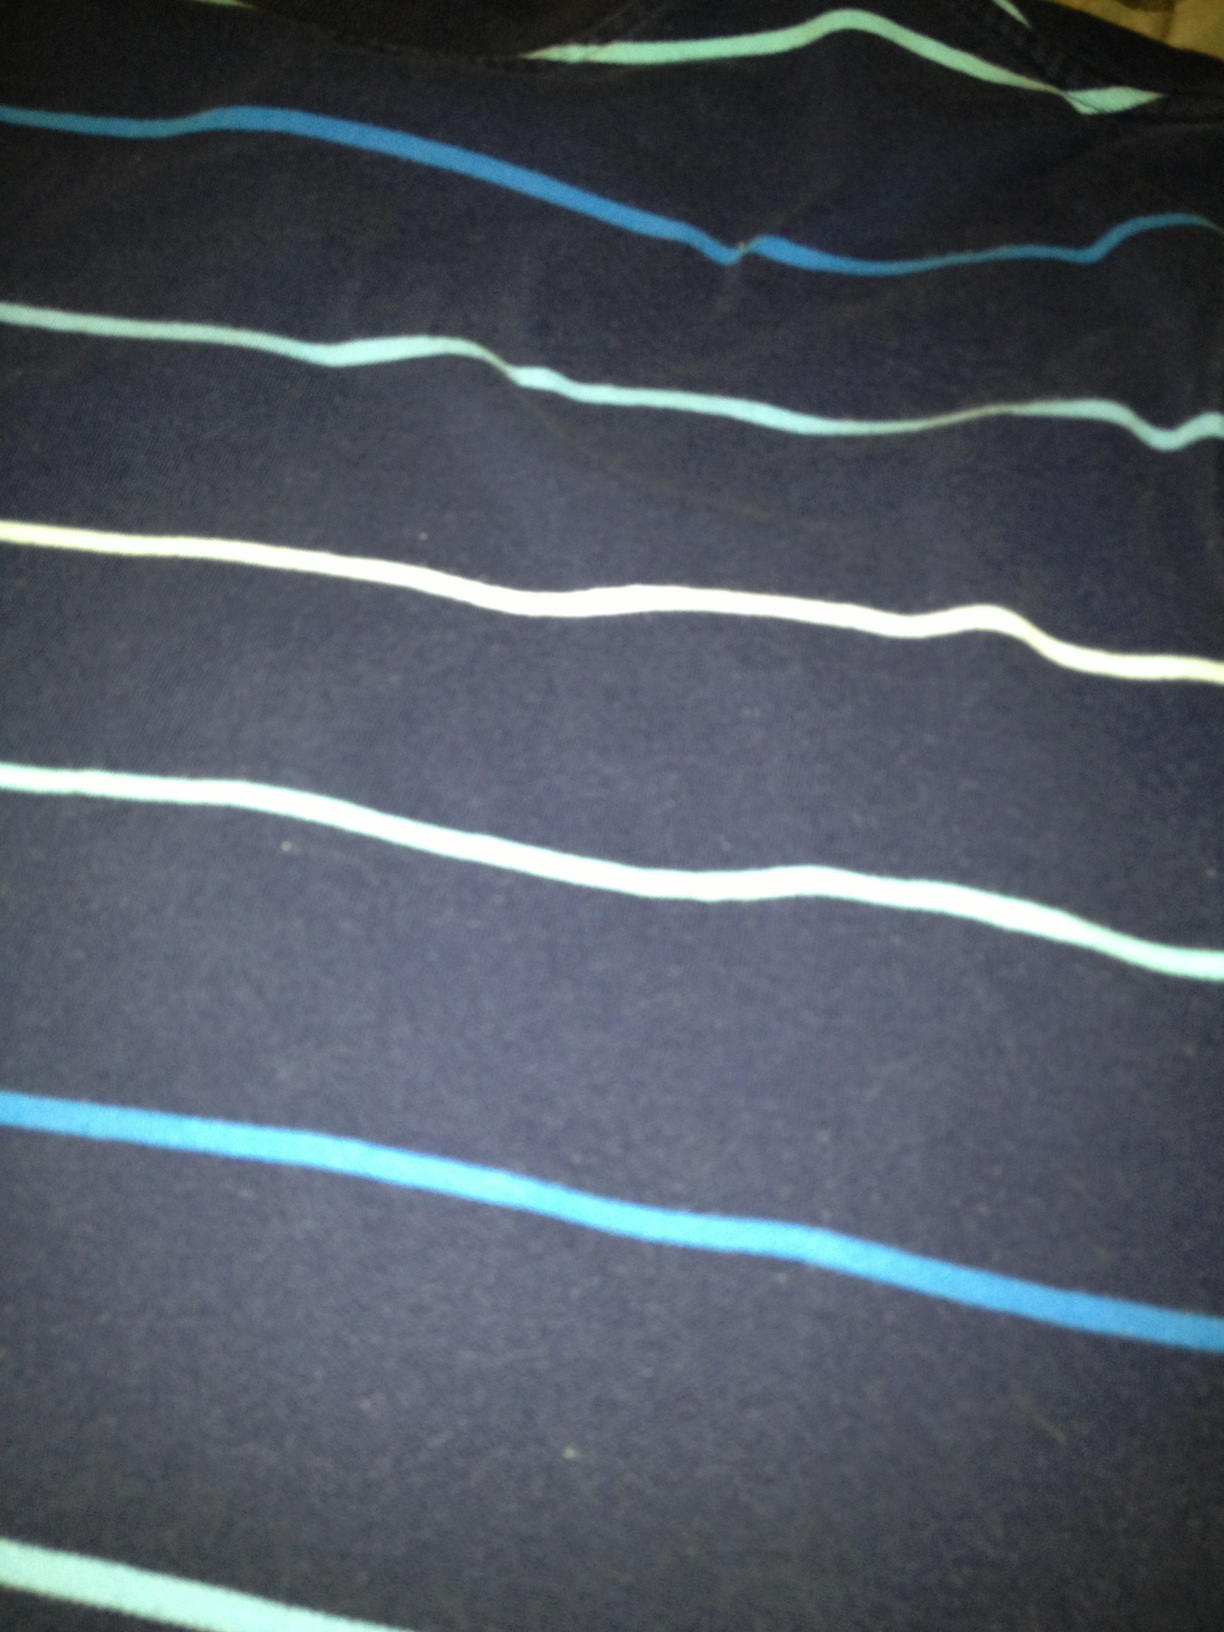Describe the pattern and style of this shirt. This shirt has a simple yet stylish design, featuring thin horizontal stripes in varying shades of blue and white against a dark grey background. The casual pattern makes it versatile for both everyday wear and casual outings. What kind of occasions would this shirt be suitable for? This shirt is perfect for casual occasions such as meeting friends, weekend outings, and relaxed gatherings. The comfortable fabric and casual design also make it suitable for a day at the park or a casual Friday at work. Can you suggest footwear that would go well with this shirt? To complement the casual look of this shirt, you could pair it with white sneakers or loafers. For a more laid-back look, sandals or espadrilles would work well too. If you're aiming for a slightly dressier look, brown leather casual shoes or boots would be a good choice. Imagine this shirt as part of a character's outfit in a story. Describe the character and the setting. In a bustling coastal town, our protagonist, Alex, often stands out with his effortlessly casual, yet stylish attire. Today, he's wearing his favorite dark grey shirt with blue and white horizontal stripes. Alex is a young artist, always carrying his sketchbook, capturing the essence of the sea and the streets of the town. His shirt mirrors the serene yet dynamic nature of his surroundings, as the blue stripes echo the waves crashing against the shore. He pairs the shirt with comfortable denim jeans and rugged brown leather boots, perfect for exploring the rocky beaches and hidden art spots. 